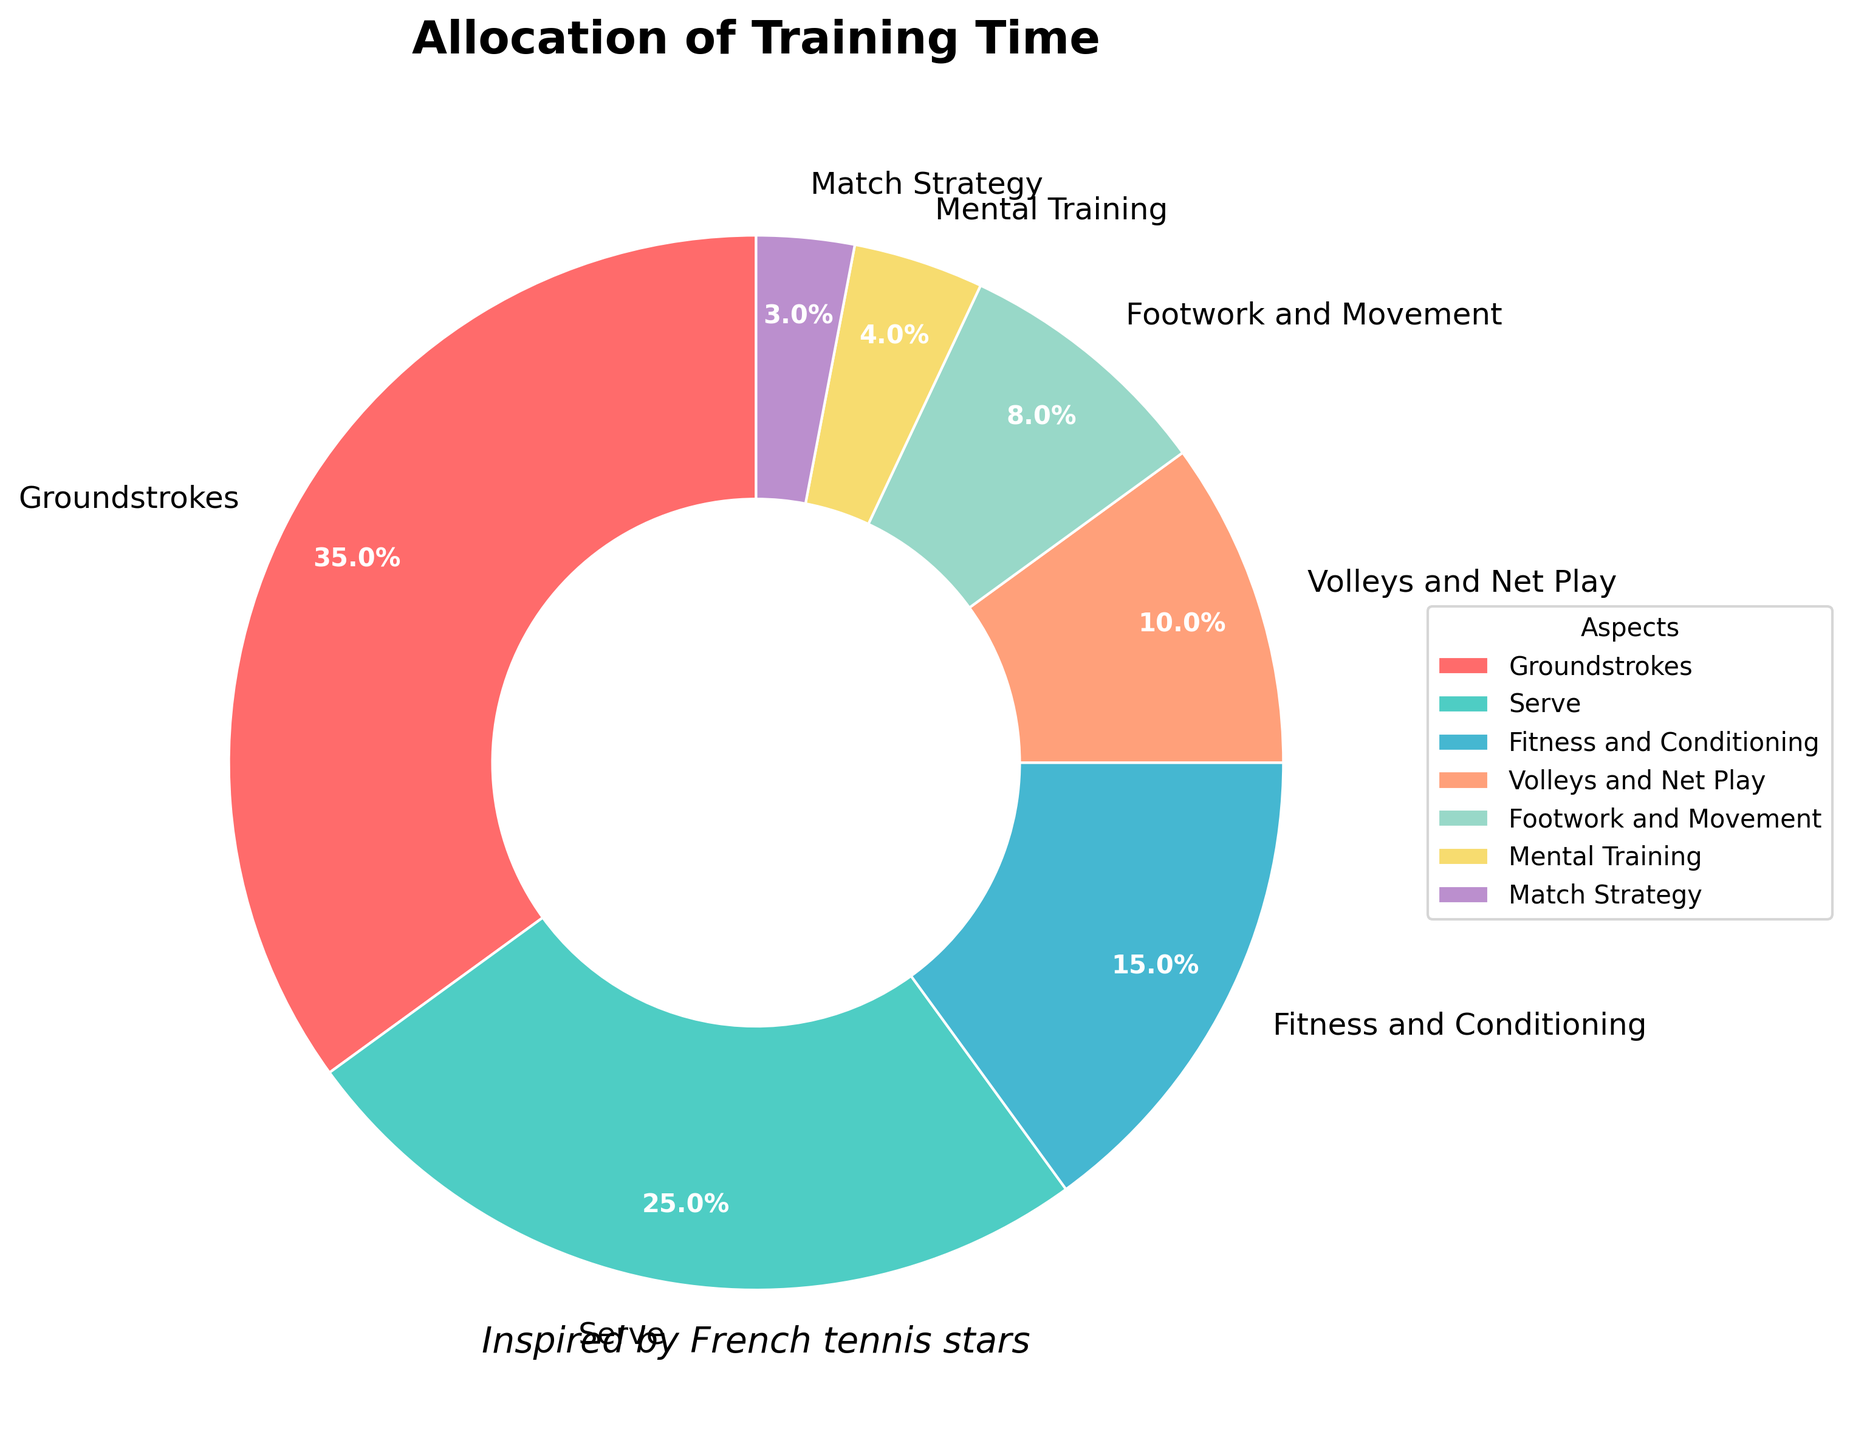What aspect of training takes up the largest percentage of time? According to the figure, the aspect of training with the largest percentage is Groundstrokes, which occupies 35% of the total training time.
Answer: Groundstrokes Which aspects combined take up exactly half of the training time? To find the aspects that sum up to 50%, we can add the percentages. Groundstrokes (35%) and Serve (25%) add up to 60%, which exceeds half. Groundstrokes (35%) and Footwork and Movement (8%) sum to 43%. Groundstrokes (35%) and Fitness and Conditioning (15%) add up to 50%. So, Groundstrokes and Fitness and Conditioning combined take up exactly half of the training time.
Answer: Groundstrokes and Fitness and Conditioning How much more time is allocated to Serve compared to Match Strategy? The percentage of time allocated to Serve is 25% and to Match Strategy is 3%. The difference is 25% - 3% = 22%.
Answer: 22% Which aspect of training is represented by the yellow wedge? By inspecting the colors in the pie chart and identifying the yellow wedge, we can match it with the labeled aspect. The yellow wedge corresponds to Fitness and Conditioning.
Answer: Fitness and Conditioning If 12 hours are spent in total training, how many hours are dedicated to Volleys and Net Play? Volleys and Net Play make up 10% of the total training time. Therefore, 10% of 12 hours = 0.10 * 12 = 1.2 hours.
Answer: 1.2 hours Which two aspects together occupy less than 10% of the training time? By examining the percentages, the aspects with the smallest contributions are Mental Training (4%) and Match Strategy (3%). Together, they sum up to 4% + 3% = 7%, which is less than 10%.
Answer: Mental Training and Match Strategy What visual attribute differentiates the Groundstrokes section from the other sections? The Groundstrokes section can be recognized by its distinctive red color and its larger wedge size compared to the other sections.
Answer: Color and wedge size Out of Groundstrokes and Fitness and Conditioning, which aspect has a greater percentage of training time? By comparing the percentages of these two aspects, Groundstrokes has 35% while Fitness and Conditioning has 15%. Groundstrokes has a greater percentage.
Answer: Groundstrokes What is the second most allocated aspect of training time? By looking at the percentages, the only aspect with a greater percentage than others except for Groundstrokes (35%) is Serve, which takes up 25% of the training time.
Answer: Serve What is the total percentage of time spent on aspects related to the net (Volley and Net Play and Serve)? Volleys and Net Play make up 10% and Serve makes up 25%. Summing these, we get 10% + 25% = 35%.
Answer: 35% 